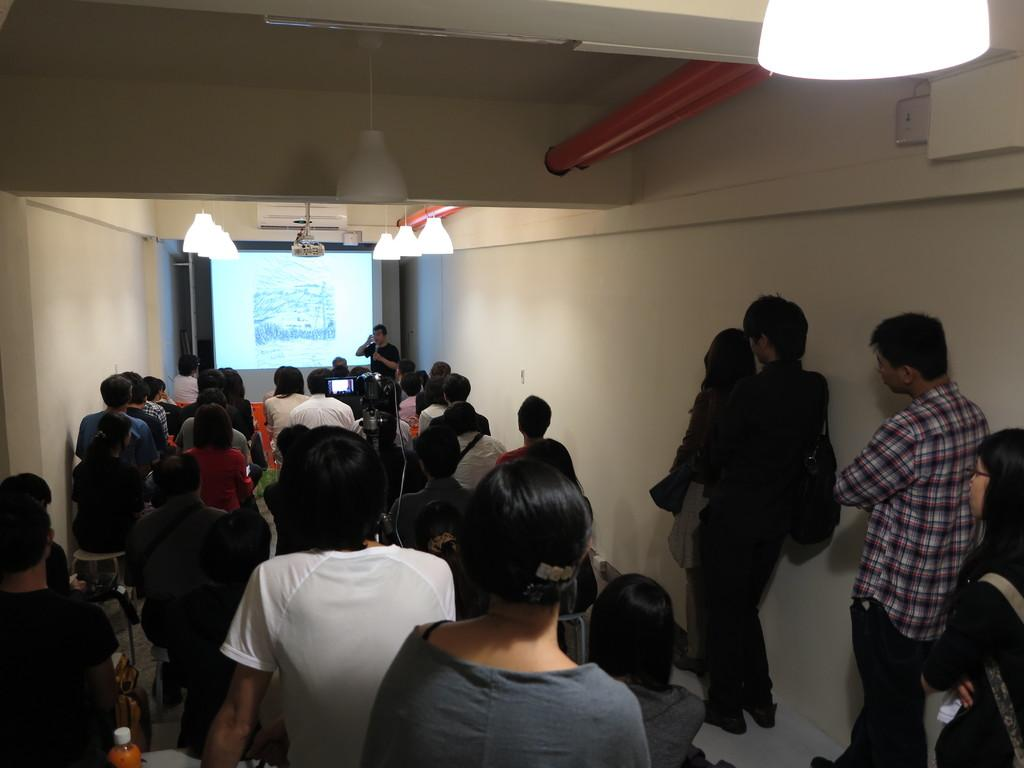What is the general arrangement of people in the image? The people are sitting one after the other in the image. What can be seen in the middle of the image? There is a screen in the middle of the image. Are there any people standing in the image? Yes, there are people standing on the right side of the image. What type of veil is draped over the screen in the image? There is no veil present in the image; the screen is visible without any covering. How many rings can be seen on the fingers of the people sitting in the image? There is no mention of rings in the image, so it is not possible to determine the number of rings present. 